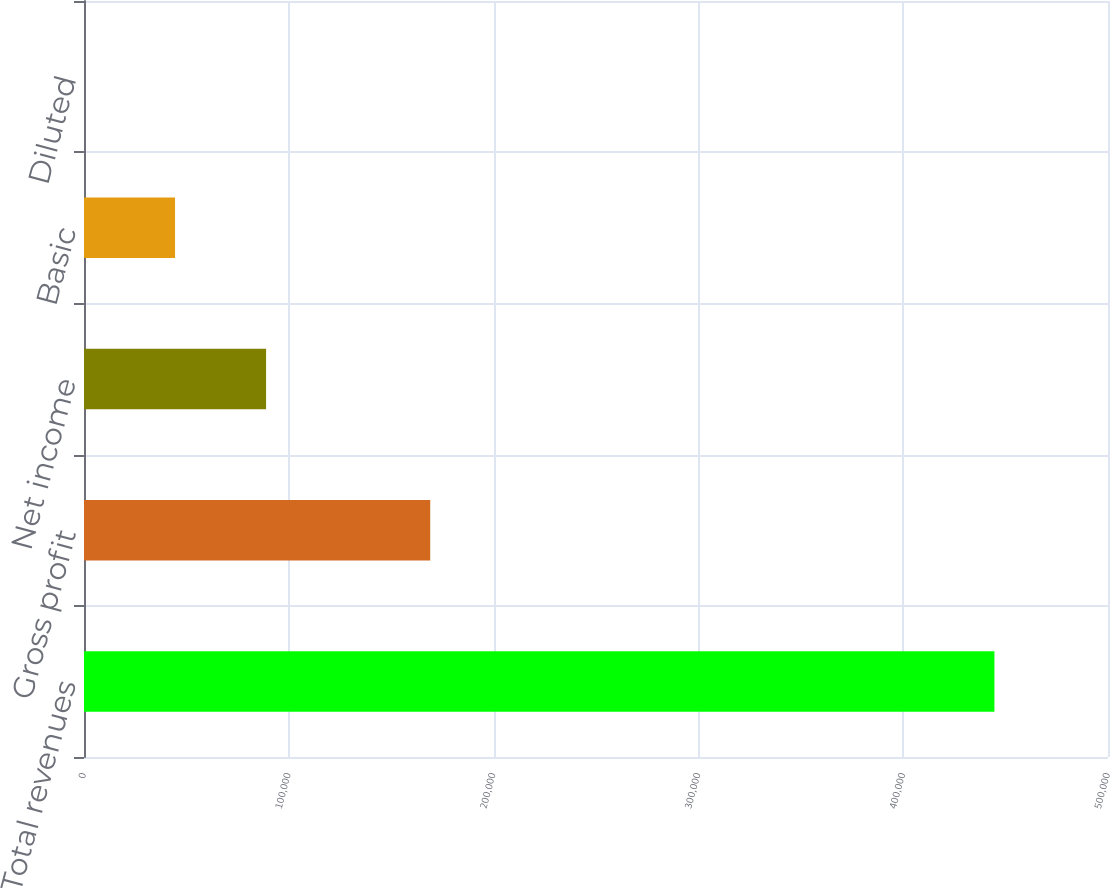Convert chart to OTSL. <chart><loc_0><loc_0><loc_500><loc_500><bar_chart><fcel>Total revenues<fcel>Gross profit<fcel>Net income<fcel>Basic<fcel>Diluted<nl><fcel>444542<fcel>169056<fcel>88908.8<fcel>44454.7<fcel>0.56<nl></chart> 